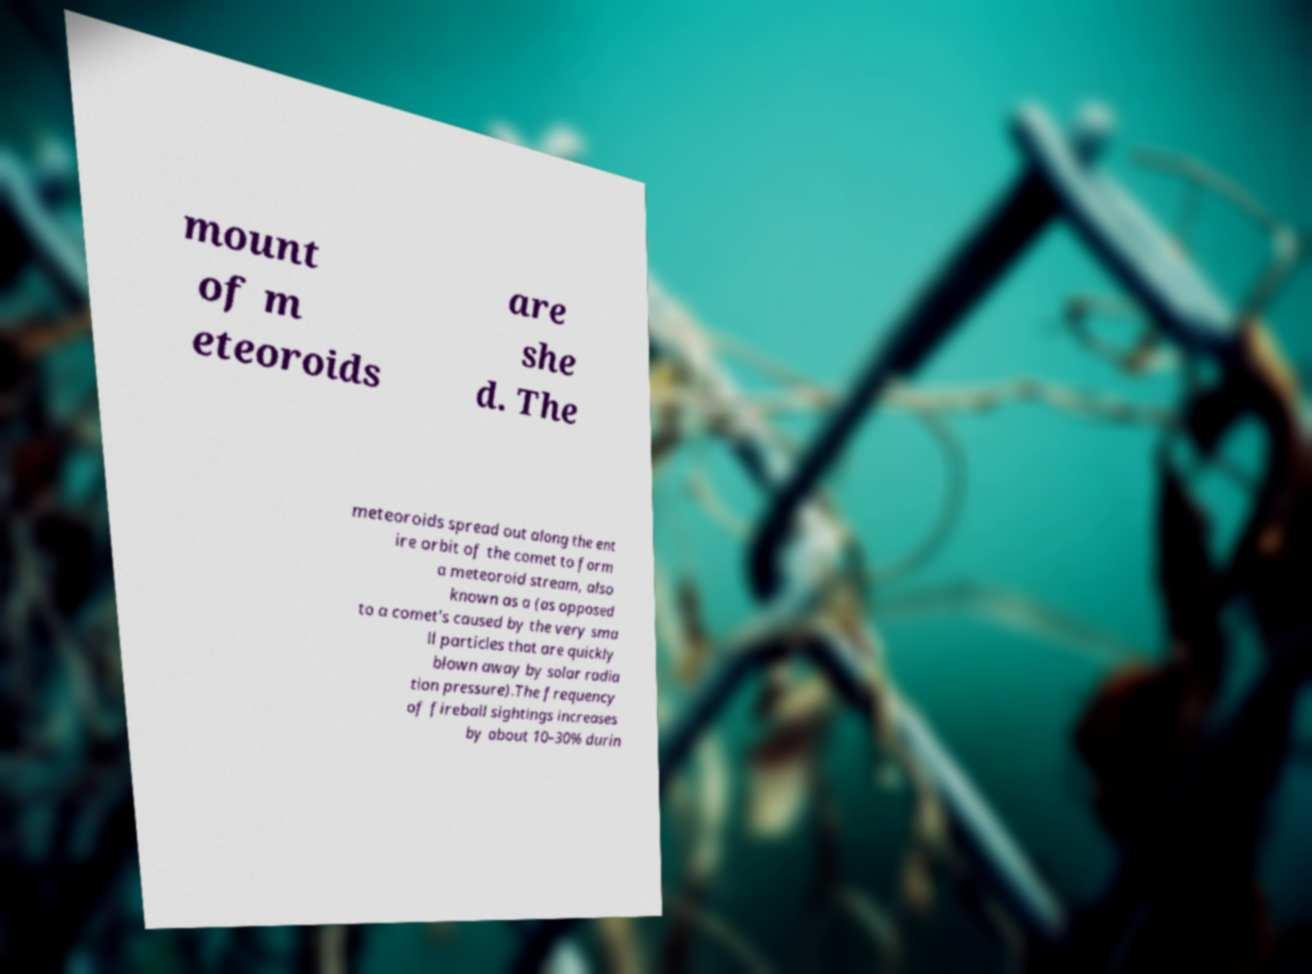I need the written content from this picture converted into text. Can you do that? mount of m eteoroids are she d. The meteoroids spread out along the ent ire orbit of the comet to form a meteoroid stream, also known as a (as opposed to a comet's caused by the very sma ll particles that are quickly blown away by solar radia tion pressure).The frequency of fireball sightings increases by about 10–30% durin 